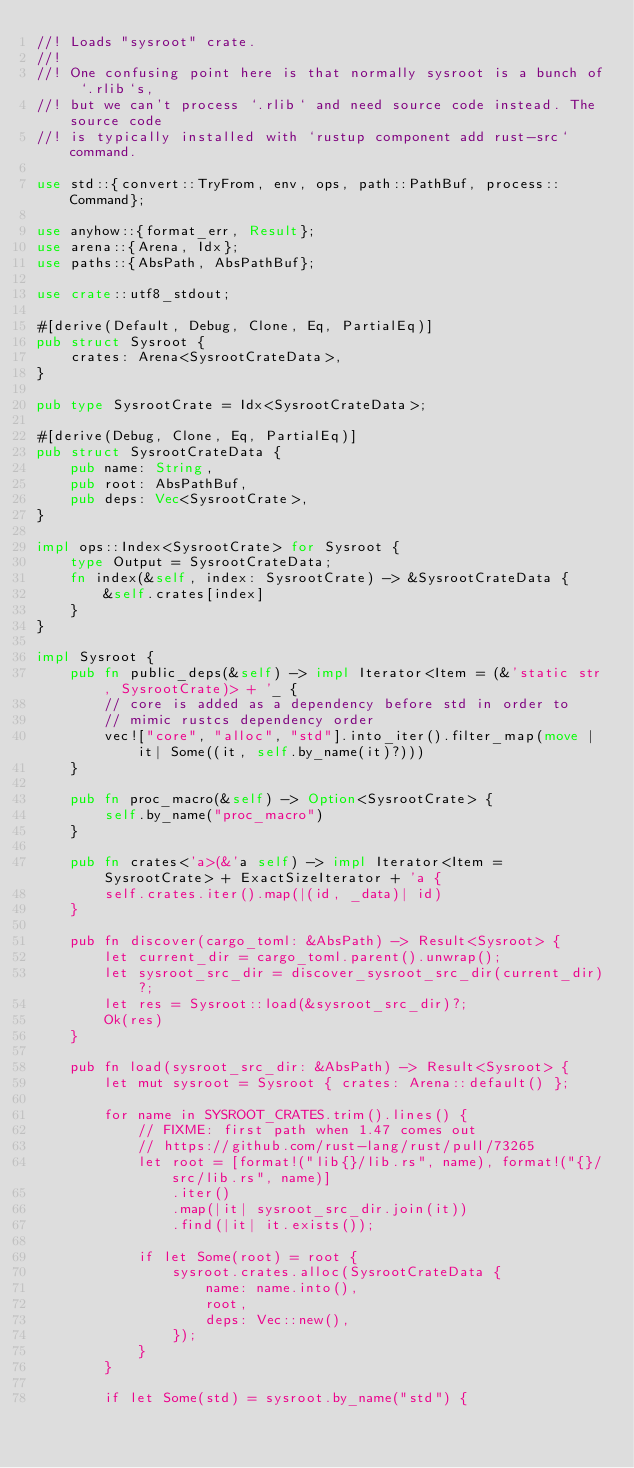<code> <loc_0><loc_0><loc_500><loc_500><_Rust_>//! Loads "sysroot" crate.
//!
//! One confusing point here is that normally sysroot is a bunch of `.rlib`s,
//! but we can't process `.rlib` and need source code instead. The source code
//! is typically installed with `rustup component add rust-src` command.

use std::{convert::TryFrom, env, ops, path::PathBuf, process::Command};

use anyhow::{format_err, Result};
use arena::{Arena, Idx};
use paths::{AbsPath, AbsPathBuf};

use crate::utf8_stdout;

#[derive(Default, Debug, Clone, Eq, PartialEq)]
pub struct Sysroot {
    crates: Arena<SysrootCrateData>,
}

pub type SysrootCrate = Idx<SysrootCrateData>;

#[derive(Debug, Clone, Eq, PartialEq)]
pub struct SysrootCrateData {
    pub name: String,
    pub root: AbsPathBuf,
    pub deps: Vec<SysrootCrate>,
}

impl ops::Index<SysrootCrate> for Sysroot {
    type Output = SysrootCrateData;
    fn index(&self, index: SysrootCrate) -> &SysrootCrateData {
        &self.crates[index]
    }
}

impl Sysroot {
    pub fn public_deps(&self) -> impl Iterator<Item = (&'static str, SysrootCrate)> + '_ {
        // core is added as a dependency before std in order to
        // mimic rustcs dependency order
        vec!["core", "alloc", "std"].into_iter().filter_map(move |it| Some((it, self.by_name(it)?)))
    }

    pub fn proc_macro(&self) -> Option<SysrootCrate> {
        self.by_name("proc_macro")
    }

    pub fn crates<'a>(&'a self) -> impl Iterator<Item = SysrootCrate> + ExactSizeIterator + 'a {
        self.crates.iter().map(|(id, _data)| id)
    }

    pub fn discover(cargo_toml: &AbsPath) -> Result<Sysroot> {
        let current_dir = cargo_toml.parent().unwrap();
        let sysroot_src_dir = discover_sysroot_src_dir(current_dir)?;
        let res = Sysroot::load(&sysroot_src_dir)?;
        Ok(res)
    }

    pub fn load(sysroot_src_dir: &AbsPath) -> Result<Sysroot> {
        let mut sysroot = Sysroot { crates: Arena::default() };

        for name in SYSROOT_CRATES.trim().lines() {
            // FIXME: first path when 1.47 comes out
            // https://github.com/rust-lang/rust/pull/73265
            let root = [format!("lib{}/lib.rs", name), format!("{}/src/lib.rs", name)]
                .iter()
                .map(|it| sysroot_src_dir.join(it))
                .find(|it| it.exists());

            if let Some(root) = root {
                sysroot.crates.alloc(SysrootCrateData {
                    name: name.into(),
                    root,
                    deps: Vec::new(),
                });
            }
        }

        if let Some(std) = sysroot.by_name("std") {</code> 